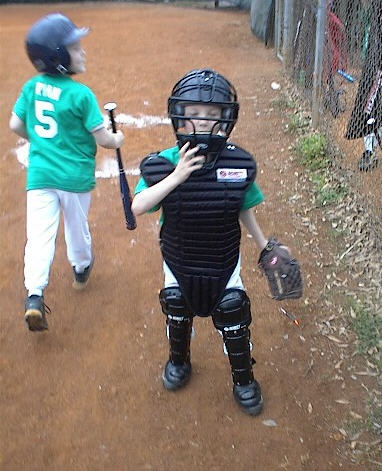Describe the objects in this image and their specific colors. I can see people in black, gray, and white tones, people in black, white, turquoise, teal, and darkgray tones, baseball glove in black and gray tones, and baseball bat in black, navy, gray, and white tones in this image. 